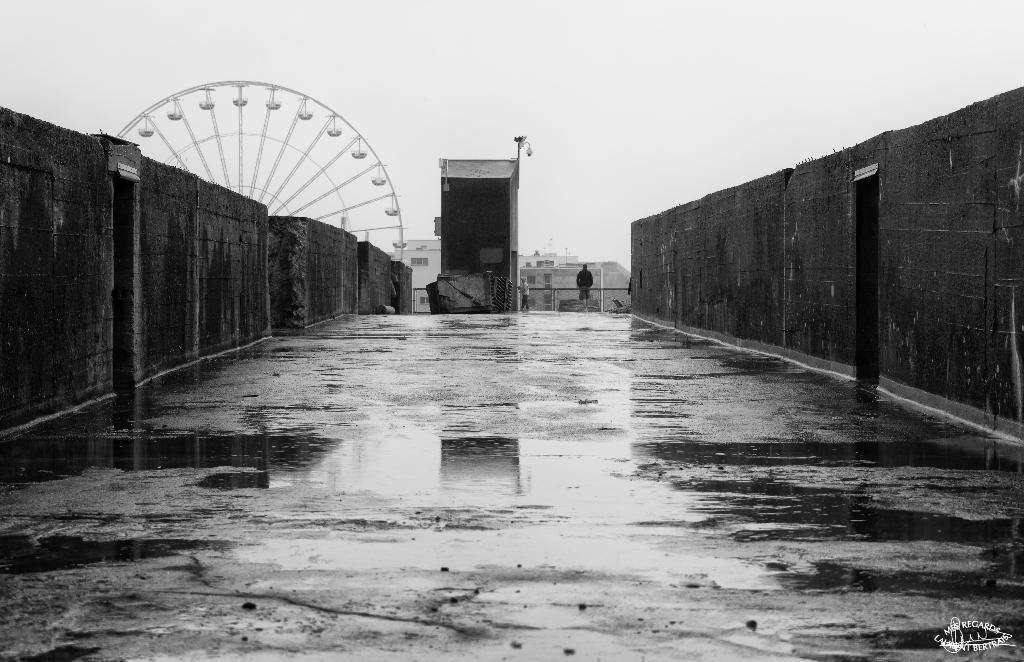In one or two sentences, can you explain what this image depicts? This is a black and white picture. Here we can see walls. We can see one person standing here, wearing a black shirt and near to him there is other person. Behind this wall there is a giant wheel. At the top of the picture we can see sky. Behind to this wall there is a building. We can see water on the floor over here. 